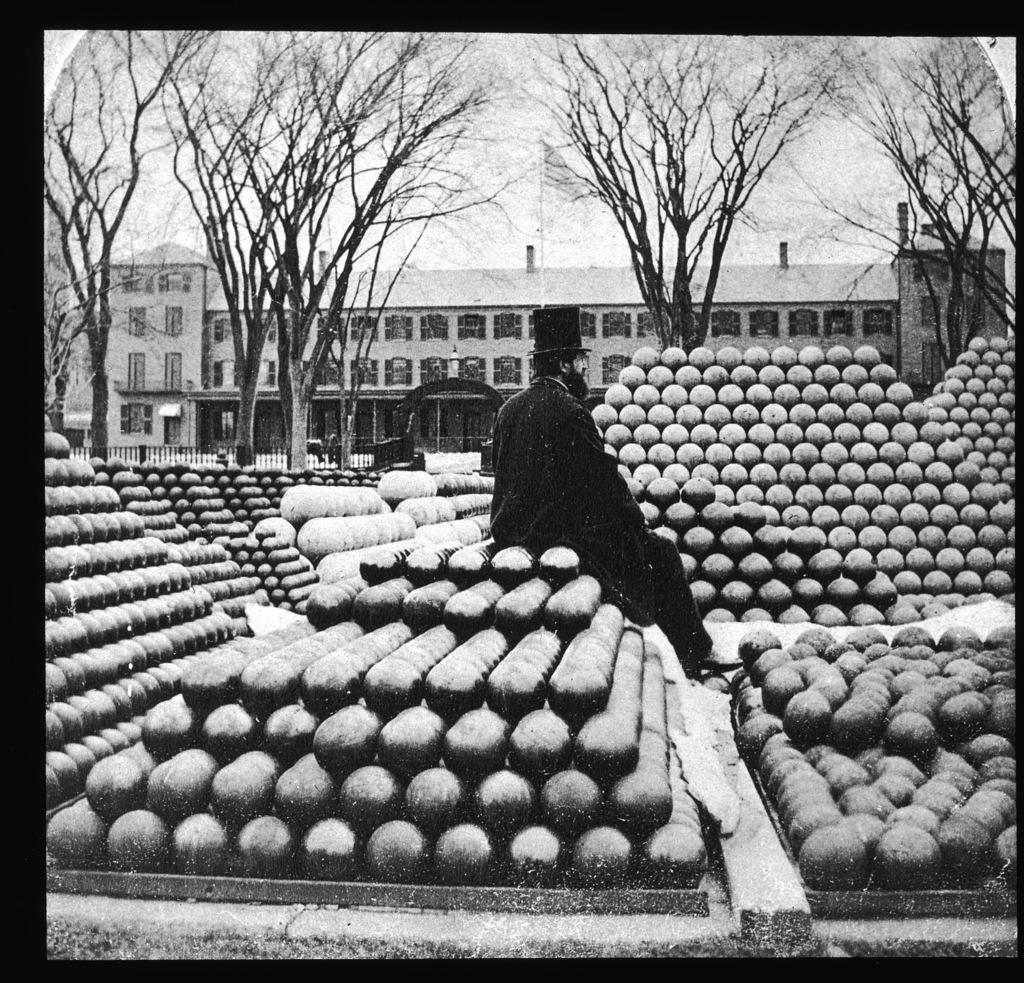Who or what is present in the image? There is a person in the image. What else can be seen in the image besides the person? There are objects in the image. What can be seen in the background of the image? There is a building, trees, a flag, and the sky visible in the background of the image. What type of copper or brass object can be seen in the image? There is no copper or brass object present in the image. How many stars are visible in the image? There are no stars visible in the image; only the sky is visible in the background. 